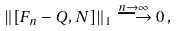<formula> <loc_0><loc_0><loc_500><loc_500>\| [ F _ { n } - Q , N ] \| _ { 1 } \stackrel { n \to \infty } { \longrightarrow } 0 \, ,</formula> 